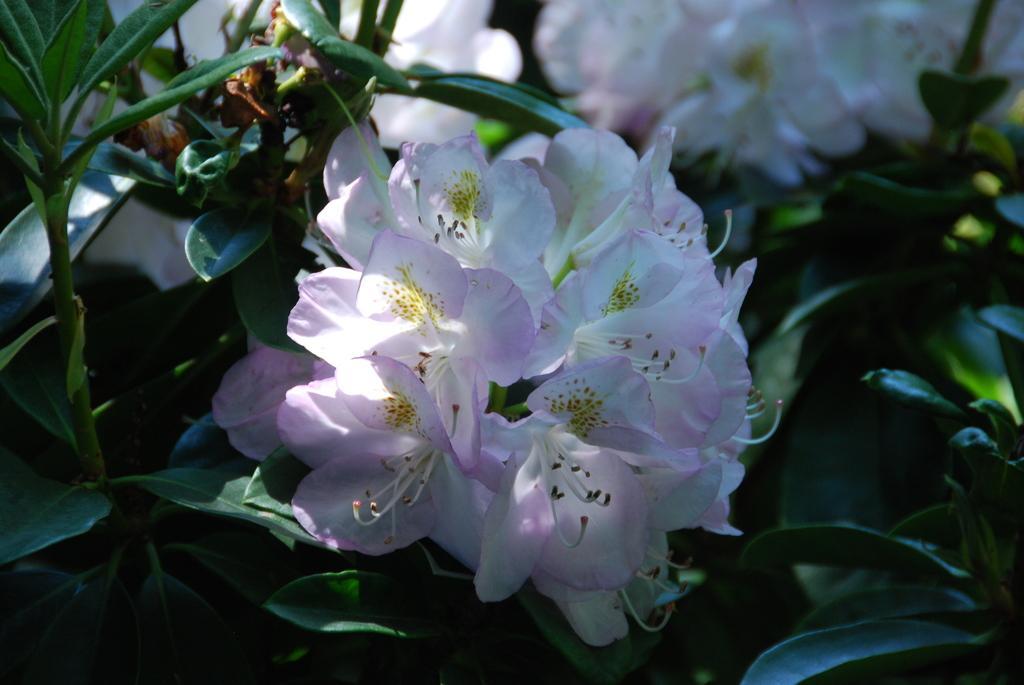Could you give a brief overview of what you see in this image? In the picture we can see group of plants and to it we can see a group of flowers which are light pink and white in color. 